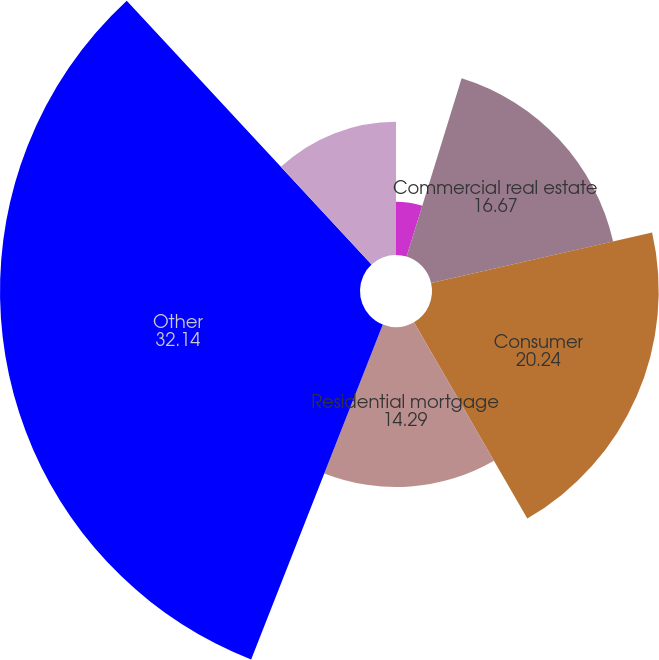<chart> <loc_0><loc_0><loc_500><loc_500><pie_chart><fcel>Commercial<fcel>Commercial real estate<fcel>Consumer<fcel>Residential mortgage<fcel>Other<fcel>Total loans<nl><fcel>4.76%<fcel>16.67%<fcel>20.24%<fcel>14.29%<fcel>32.14%<fcel>11.9%<nl></chart> 